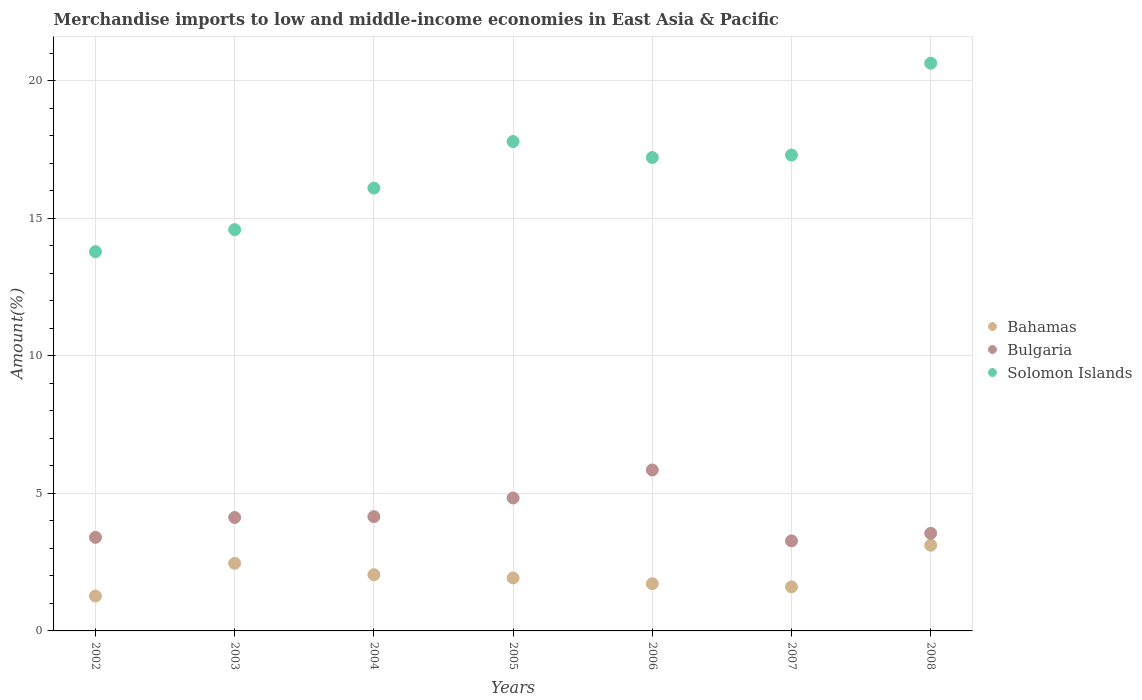How many different coloured dotlines are there?
Keep it short and to the point. 3. What is the percentage of amount earned from merchandise imports in Bahamas in 2006?
Your answer should be very brief. 1.72. Across all years, what is the maximum percentage of amount earned from merchandise imports in Solomon Islands?
Give a very brief answer. 20.64. Across all years, what is the minimum percentage of amount earned from merchandise imports in Bulgaria?
Offer a terse response. 3.27. What is the total percentage of amount earned from merchandise imports in Bahamas in the graph?
Your response must be concise. 14.13. What is the difference between the percentage of amount earned from merchandise imports in Bahamas in 2002 and that in 2008?
Give a very brief answer. -1.85. What is the difference between the percentage of amount earned from merchandise imports in Bulgaria in 2003 and the percentage of amount earned from merchandise imports in Solomon Islands in 2007?
Give a very brief answer. -13.18. What is the average percentage of amount earned from merchandise imports in Solomon Islands per year?
Your answer should be very brief. 16.78. In the year 2006, what is the difference between the percentage of amount earned from merchandise imports in Solomon Islands and percentage of amount earned from merchandise imports in Bulgaria?
Make the answer very short. 11.36. What is the ratio of the percentage of amount earned from merchandise imports in Solomon Islands in 2003 to that in 2007?
Your response must be concise. 0.84. Is the difference between the percentage of amount earned from merchandise imports in Solomon Islands in 2004 and 2007 greater than the difference between the percentage of amount earned from merchandise imports in Bulgaria in 2004 and 2007?
Ensure brevity in your answer.  No. What is the difference between the highest and the second highest percentage of amount earned from merchandise imports in Bulgaria?
Your answer should be compact. 1.02. What is the difference between the highest and the lowest percentage of amount earned from merchandise imports in Bulgaria?
Provide a short and direct response. 2.58. In how many years, is the percentage of amount earned from merchandise imports in Bahamas greater than the average percentage of amount earned from merchandise imports in Bahamas taken over all years?
Offer a very short reply. 3. Is the sum of the percentage of amount earned from merchandise imports in Solomon Islands in 2003 and 2007 greater than the maximum percentage of amount earned from merchandise imports in Bahamas across all years?
Offer a very short reply. Yes. Is it the case that in every year, the sum of the percentage of amount earned from merchandise imports in Bahamas and percentage of amount earned from merchandise imports in Bulgaria  is greater than the percentage of amount earned from merchandise imports in Solomon Islands?
Ensure brevity in your answer.  No. How many years are there in the graph?
Your response must be concise. 7. What is the difference between two consecutive major ticks on the Y-axis?
Provide a short and direct response. 5. Does the graph contain grids?
Provide a short and direct response. Yes. How are the legend labels stacked?
Offer a very short reply. Vertical. What is the title of the graph?
Your answer should be very brief. Merchandise imports to low and middle-income economies in East Asia & Pacific. What is the label or title of the X-axis?
Your answer should be very brief. Years. What is the label or title of the Y-axis?
Your answer should be compact. Amount(%). What is the Amount(%) of Bahamas in 2002?
Ensure brevity in your answer.  1.27. What is the Amount(%) of Bulgaria in 2002?
Ensure brevity in your answer.  3.4. What is the Amount(%) of Solomon Islands in 2002?
Keep it short and to the point. 13.79. What is the Amount(%) in Bahamas in 2003?
Give a very brief answer. 2.46. What is the Amount(%) of Bulgaria in 2003?
Keep it short and to the point. 4.12. What is the Amount(%) of Solomon Islands in 2003?
Ensure brevity in your answer.  14.59. What is the Amount(%) in Bahamas in 2004?
Offer a terse response. 2.04. What is the Amount(%) in Bulgaria in 2004?
Offer a very short reply. 4.15. What is the Amount(%) of Solomon Islands in 2004?
Provide a short and direct response. 16.1. What is the Amount(%) of Bahamas in 2005?
Give a very brief answer. 1.93. What is the Amount(%) of Bulgaria in 2005?
Keep it short and to the point. 4.83. What is the Amount(%) of Solomon Islands in 2005?
Give a very brief answer. 17.79. What is the Amount(%) of Bahamas in 2006?
Your response must be concise. 1.72. What is the Amount(%) in Bulgaria in 2006?
Ensure brevity in your answer.  5.85. What is the Amount(%) of Solomon Islands in 2006?
Offer a terse response. 17.21. What is the Amount(%) of Bahamas in 2007?
Offer a very short reply. 1.6. What is the Amount(%) in Bulgaria in 2007?
Your answer should be very brief. 3.27. What is the Amount(%) of Solomon Islands in 2007?
Ensure brevity in your answer.  17.3. What is the Amount(%) in Bahamas in 2008?
Give a very brief answer. 3.12. What is the Amount(%) of Bulgaria in 2008?
Ensure brevity in your answer.  3.55. What is the Amount(%) in Solomon Islands in 2008?
Provide a succinct answer. 20.64. Across all years, what is the maximum Amount(%) in Bahamas?
Offer a very short reply. 3.12. Across all years, what is the maximum Amount(%) in Bulgaria?
Your answer should be compact. 5.85. Across all years, what is the maximum Amount(%) of Solomon Islands?
Provide a succinct answer. 20.64. Across all years, what is the minimum Amount(%) of Bahamas?
Offer a very short reply. 1.27. Across all years, what is the minimum Amount(%) in Bulgaria?
Provide a succinct answer. 3.27. Across all years, what is the minimum Amount(%) in Solomon Islands?
Make the answer very short. 13.79. What is the total Amount(%) in Bahamas in the graph?
Your response must be concise. 14.13. What is the total Amount(%) of Bulgaria in the graph?
Your response must be concise. 29.19. What is the total Amount(%) in Solomon Islands in the graph?
Your response must be concise. 117.44. What is the difference between the Amount(%) of Bahamas in 2002 and that in 2003?
Your answer should be very brief. -1.19. What is the difference between the Amount(%) of Bulgaria in 2002 and that in 2003?
Keep it short and to the point. -0.72. What is the difference between the Amount(%) of Solomon Islands in 2002 and that in 2003?
Your answer should be very brief. -0.8. What is the difference between the Amount(%) in Bahamas in 2002 and that in 2004?
Make the answer very short. -0.78. What is the difference between the Amount(%) of Bulgaria in 2002 and that in 2004?
Ensure brevity in your answer.  -0.75. What is the difference between the Amount(%) of Solomon Islands in 2002 and that in 2004?
Provide a short and direct response. -2.31. What is the difference between the Amount(%) in Bahamas in 2002 and that in 2005?
Offer a terse response. -0.66. What is the difference between the Amount(%) of Bulgaria in 2002 and that in 2005?
Offer a very short reply. -1.43. What is the difference between the Amount(%) of Solomon Islands in 2002 and that in 2005?
Offer a very short reply. -4. What is the difference between the Amount(%) in Bahamas in 2002 and that in 2006?
Keep it short and to the point. -0.45. What is the difference between the Amount(%) of Bulgaria in 2002 and that in 2006?
Offer a very short reply. -2.45. What is the difference between the Amount(%) of Solomon Islands in 2002 and that in 2006?
Your answer should be compact. -3.42. What is the difference between the Amount(%) in Bahamas in 2002 and that in 2007?
Give a very brief answer. -0.33. What is the difference between the Amount(%) in Bulgaria in 2002 and that in 2007?
Your answer should be compact. 0.13. What is the difference between the Amount(%) of Solomon Islands in 2002 and that in 2007?
Your answer should be compact. -3.51. What is the difference between the Amount(%) in Bahamas in 2002 and that in 2008?
Your answer should be very brief. -1.85. What is the difference between the Amount(%) in Bulgaria in 2002 and that in 2008?
Your response must be concise. -0.15. What is the difference between the Amount(%) of Solomon Islands in 2002 and that in 2008?
Offer a very short reply. -6.85. What is the difference between the Amount(%) of Bahamas in 2003 and that in 2004?
Your answer should be very brief. 0.41. What is the difference between the Amount(%) in Bulgaria in 2003 and that in 2004?
Make the answer very short. -0.03. What is the difference between the Amount(%) of Solomon Islands in 2003 and that in 2004?
Your response must be concise. -1.51. What is the difference between the Amount(%) in Bahamas in 2003 and that in 2005?
Your answer should be compact. 0.53. What is the difference between the Amount(%) of Bulgaria in 2003 and that in 2005?
Your answer should be compact. -0.71. What is the difference between the Amount(%) in Solomon Islands in 2003 and that in 2005?
Your answer should be compact. -3.2. What is the difference between the Amount(%) of Bahamas in 2003 and that in 2006?
Your response must be concise. 0.74. What is the difference between the Amount(%) of Bulgaria in 2003 and that in 2006?
Ensure brevity in your answer.  -1.73. What is the difference between the Amount(%) of Solomon Islands in 2003 and that in 2006?
Offer a terse response. -2.62. What is the difference between the Amount(%) of Bahamas in 2003 and that in 2007?
Offer a very short reply. 0.86. What is the difference between the Amount(%) of Bulgaria in 2003 and that in 2007?
Provide a short and direct response. 0.85. What is the difference between the Amount(%) of Solomon Islands in 2003 and that in 2007?
Ensure brevity in your answer.  -2.71. What is the difference between the Amount(%) in Bahamas in 2003 and that in 2008?
Give a very brief answer. -0.66. What is the difference between the Amount(%) in Bulgaria in 2003 and that in 2008?
Offer a very short reply. 0.57. What is the difference between the Amount(%) in Solomon Islands in 2003 and that in 2008?
Your response must be concise. -6.05. What is the difference between the Amount(%) in Bahamas in 2004 and that in 2005?
Your answer should be very brief. 0.12. What is the difference between the Amount(%) in Bulgaria in 2004 and that in 2005?
Give a very brief answer. -0.68. What is the difference between the Amount(%) of Solomon Islands in 2004 and that in 2005?
Provide a short and direct response. -1.69. What is the difference between the Amount(%) of Bahamas in 2004 and that in 2006?
Provide a succinct answer. 0.33. What is the difference between the Amount(%) of Bulgaria in 2004 and that in 2006?
Provide a succinct answer. -1.7. What is the difference between the Amount(%) in Solomon Islands in 2004 and that in 2006?
Your answer should be very brief. -1.11. What is the difference between the Amount(%) of Bahamas in 2004 and that in 2007?
Provide a short and direct response. 0.44. What is the difference between the Amount(%) in Bulgaria in 2004 and that in 2007?
Ensure brevity in your answer.  0.88. What is the difference between the Amount(%) in Solomon Islands in 2004 and that in 2007?
Ensure brevity in your answer.  -1.2. What is the difference between the Amount(%) in Bahamas in 2004 and that in 2008?
Give a very brief answer. -1.07. What is the difference between the Amount(%) in Bulgaria in 2004 and that in 2008?
Make the answer very short. 0.61. What is the difference between the Amount(%) in Solomon Islands in 2004 and that in 2008?
Provide a short and direct response. -4.54. What is the difference between the Amount(%) in Bahamas in 2005 and that in 2006?
Make the answer very short. 0.21. What is the difference between the Amount(%) of Bulgaria in 2005 and that in 2006?
Your answer should be compact. -1.02. What is the difference between the Amount(%) of Solomon Islands in 2005 and that in 2006?
Your response must be concise. 0.58. What is the difference between the Amount(%) of Bahamas in 2005 and that in 2007?
Give a very brief answer. 0.33. What is the difference between the Amount(%) in Bulgaria in 2005 and that in 2007?
Your answer should be very brief. 1.56. What is the difference between the Amount(%) of Solomon Islands in 2005 and that in 2007?
Your answer should be compact. 0.49. What is the difference between the Amount(%) in Bahamas in 2005 and that in 2008?
Ensure brevity in your answer.  -1.19. What is the difference between the Amount(%) of Bulgaria in 2005 and that in 2008?
Your answer should be compact. 1.29. What is the difference between the Amount(%) of Solomon Islands in 2005 and that in 2008?
Offer a very short reply. -2.85. What is the difference between the Amount(%) in Bahamas in 2006 and that in 2007?
Ensure brevity in your answer.  0.11. What is the difference between the Amount(%) of Bulgaria in 2006 and that in 2007?
Make the answer very short. 2.58. What is the difference between the Amount(%) in Solomon Islands in 2006 and that in 2007?
Offer a terse response. -0.09. What is the difference between the Amount(%) in Bahamas in 2006 and that in 2008?
Offer a terse response. -1.4. What is the difference between the Amount(%) of Bulgaria in 2006 and that in 2008?
Provide a short and direct response. 2.3. What is the difference between the Amount(%) in Solomon Islands in 2006 and that in 2008?
Provide a short and direct response. -3.43. What is the difference between the Amount(%) in Bahamas in 2007 and that in 2008?
Your answer should be compact. -1.51. What is the difference between the Amount(%) in Bulgaria in 2007 and that in 2008?
Ensure brevity in your answer.  -0.28. What is the difference between the Amount(%) in Solomon Islands in 2007 and that in 2008?
Your answer should be very brief. -3.34. What is the difference between the Amount(%) of Bahamas in 2002 and the Amount(%) of Bulgaria in 2003?
Make the answer very short. -2.86. What is the difference between the Amount(%) of Bahamas in 2002 and the Amount(%) of Solomon Islands in 2003?
Offer a terse response. -13.32. What is the difference between the Amount(%) in Bulgaria in 2002 and the Amount(%) in Solomon Islands in 2003?
Keep it short and to the point. -11.19. What is the difference between the Amount(%) of Bahamas in 2002 and the Amount(%) of Bulgaria in 2004?
Offer a very short reply. -2.89. What is the difference between the Amount(%) of Bahamas in 2002 and the Amount(%) of Solomon Islands in 2004?
Make the answer very short. -14.83. What is the difference between the Amount(%) in Bulgaria in 2002 and the Amount(%) in Solomon Islands in 2004?
Give a very brief answer. -12.7. What is the difference between the Amount(%) of Bahamas in 2002 and the Amount(%) of Bulgaria in 2005?
Make the answer very short. -3.57. What is the difference between the Amount(%) of Bahamas in 2002 and the Amount(%) of Solomon Islands in 2005?
Your answer should be very brief. -16.53. What is the difference between the Amount(%) of Bulgaria in 2002 and the Amount(%) of Solomon Islands in 2005?
Keep it short and to the point. -14.39. What is the difference between the Amount(%) in Bahamas in 2002 and the Amount(%) in Bulgaria in 2006?
Provide a short and direct response. -4.58. What is the difference between the Amount(%) in Bahamas in 2002 and the Amount(%) in Solomon Islands in 2006?
Offer a terse response. -15.95. What is the difference between the Amount(%) in Bulgaria in 2002 and the Amount(%) in Solomon Islands in 2006?
Your response must be concise. -13.81. What is the difference between the Amount(%) of Bahamas in 2002 and the Amount(%) of Bulgaria in 2007?
Keep it short and to the point. -2.01. What is the difference between the Amount(%) of Bahamas in 2002 and the Amount(%) of Solomon Islands in 2007?
Your response must be concise. -16.04. What is the difference between the Amount(%) in Bulgaria in 2002 and the Amount(%) in Solomon Islands in 2007?
Your answer should be compact. -13.9. What is the difference between the Amount(%) of Bahamas in 2002 and the Amount(%) of Bulgaria in 2008?
Your answer should be very brief. -2.28. What is the difference between the Amount(%) of Bahamas in 2002 and the Amount(%) of Solomon Islands in 2008?
Your response must be concise. -19.37. What is the difference between the Amount(%) in Bulgaria in 2002 and the Amount(%) in Solomon Islands in 2008?
Your answer should be compact. -17.24. What is the difference between the Amount(%) in Bahamas in 2003 and the Amount(%) in Bulgaria in 2004?
Your answer should be very brief. -1.7. What is the difference between the Amount(%) in Bahamas in 2003 and the Amount(%) in Solomon Islands in 2004?
Keep it short and to the point. -13.64. What is the difference between the Amount(%) in Bulgaria in 2003 and the Amount(%) in Solomon Islands in 2004?
Provide a short and direct response. -11.98. What is the difference between the Amount(%) in Bahamas in 2003 and the Amount(%) in Bulgaria in 2005?
Your answer should be very brief. -2.38. What is the difference between the Amount(%) in Bahamas in 2003 and the Amount(%) in Solomon Islands in 2005?
Give a very brief answer. -15.34. What is the difference between the Amount(%) in Bulgaria in 2003 and the Amount(%) in Solomon Islands in 2005?
Your answer should be compact. -13.67. What is the difference between the Amount(%) of Bahamas in 2003 and the Amount(%) of Bulgaria in 2006?
Give a very brief answer. -3.39. What is the difference between the Amount(%) of Bahamas in 2003 and the Amount(%) of Solomon Islands in 2006?
Ensure brevity in your answer.  -14.76. What is the difference between the Amount(%) in Bulgaria in 2003 and the Amount(%) in Solomon Islands in 2006?
Your answer should be compact. -13.09. What is the difference between the Amount(%) of Bahamas in 2003 and the Amount(%) of Bulgaria in 2007?
Your answer should be very brief. -0.82. What is the difference between the Amount(%) in Bahamas in 2003 and the Amount(%) in Solomon Islands in 2007?
Your answer should be compact. -14.85. What is the difference between the Amount(%) in Bulgaria in 2003 and the Amount(%) in Solomon Islands in 2007?
Your answer should be very brief. -13.18. What is the difference between the Amount(%) of Bahamas in 2003 and the Amount(%) of Bulgaria in 2008?
Your answer should be compact. -1.09. What is the difference between the Amount(%) of Bahamas in 2003 and the Amount(%) of Solomon Islands in 2008?
Your response must be concise. -18.18. What is the difference between the Amount(%) in Bulgaria in 2003 and the Amount(%) in Solomon Islands in 2008?
Ensure brevity in your answer.  -16.52. What is the difference between the Amount(%) in Bahamas in 2004 and the Amount(%) in Bulgaria in 2005?
Your answer should be compact. -2.79. What is the difference between the Amount(%) in Bahamas in 2004 and the Amount(%) in Solomon Islands in 2005?
Give a very brief answer. -15.75. What is the difference between the Amount(%) in Bulgaria in 2004 and the Amount(%) in Solomon Islands in 2005?
Make the answer very short. -13.64. What is the difference between the Amount(%) of Bahamas in 2004 and the Amount(%) of Bulgaria in 2006?
Your answer should be very brief. -3.81. What is the difference between the Amount(%) of Bahamas in 2004 and the Amount(%) of Solomon Islands in 2006?
Offer a terse response. -15.17. What is the difference between the Amount(%) of Bulgaria in 2004 and the Amount(%) of Solomon Islands in 2006?
Make the answer very short. -13.06. What is the difference between the Amount(%) in Bahamas in 2004 and the Amount(%) in Bulgaria in 2007?
Ensure brevity in your answer.  -1.23. What is the difference between the Amount(%) of Bahamas in 2004 and the Amount(%) of Solomon Islands in 2007?
Provide a short and direct response. -15.26. What is the difference between the Amount(%) in Bulgaria in 2004 and the Amount(%) in Solomon Islands in 2007?
Your answer should be compact. -13.15. What is the difference between the Amount(%) in Bahamas in 2004 and the Amount(%) in Bulgaria in 2008?
Keep it short and to the point. -1.5. What is the difference between the Amount(%) in Bahamas in 2004 and the Amount(%) in Solomon Islands in 2008?
Make the answer very short. -18.6. What is the difference between the Amount(%) of Bulgaria in 2004 and the Amount(%) of Solomon Islands in 2008?
Your response must be concise. -16.49. What is the difference between the Amount(%) in Bahamas in 2005 and the Amount(%) in Bulgaria in 2006?
Provide a succinct answer. -3.92. What is the difference between the Amount(%) in Bahamas in 2005 and the Amount(%) in Solomon Islands in 2006?
Your answer should be very brief. -15.29. What is the difference between the Amount(%) in Bulgaria in 2005 and the Amount(%) in Solomon Islands in 2006?
Make the answer very short. -12.38. What is the difference between the Amount(%) in Bahamas in 2005 and the Amount(%) in Bulgaria in 2007?
Provide a short and direct response. -1.35. What is the difference between the Amount(%) of Bahamas in 2005 and the Amount(%) of Solomon Islands in 2007?
Make the answer very short. -15.38. What is the difference between the Amount(%) in Bulgaria in 2005 and the Amount(%) in Solomon Islands in 2007?
Your response must be concise. -12.47. What is the difference between the Amount(%) of Bahamas in 2005 and the Amount(%) of Bulgaria in 2008?
Ensure brevity in your answer.  -1.62. What is the difference between the Amount(%) in Bahamas in 2005 and the Amount(%) in Solomon Islands in 2008?
Your answer should be very brief. -18.72. What is the difference between the Amount(%) of Bulgaria in 2005 and the Amount(%) of Solomon Islands in 2008?
Offer a terse response. -15.81. What is the difference between the Amount(%) of Bahamas in 2006 and the Amount(%) of Bulgaria in 2007?
Provide a short and direct response. -1.56. What is the difference between the Amount(%) in Bahamas in 2006 and the Amount(%) in Solomon Islands in 2007?
Your answer should be very brief. -15.59. What is the difference between the Amount(%) of Bulgaria in 2006 and the Amount(%) of Solomon Islands in 2007?
Offer a very short reply. -11.45. What is the difference between the Amount(%) in Bahamas in 2006 and the Amount(%) in Bulgaria in 2008?
Ensure brevity in your answer.  -1.83. What is the difference between the Amount(%) of Bahamas in 2006 and the Amount(%) of Solomon Islands in 2008?
Make the answer very short. -18.93. What is the difference between the Amount(%) in Bulgaria in 2006 and the Amount(%) in Solomon Islands in 2008?
Offer a terse response. -14.79. What is the difference between the Amount(%) of Bahamas in 2007 and the Amount(%) of Bulgaria in 2008?
Give a very brief answer. -1.95. What is the difference between the Amount(%) in Bahamas in 2007 and the Amount(%) in Solomon Islands in 2008?
Keep it short and to the point. -19.04. What is the difference between the Amount(%) of Bulgaria in 2007 and the Amount(%) of Solomon Islands in 2008?
Make the answer very short. -17.37. What is the average Amount(%) of Bahamas per year?
Give a very brief answer. 2.02. What is the average Amount(%) in Bulgaria per year?
Provide a short and direct response. 4.17. What is the average Amount(%) in Solomon Islands per year?
Provide a short and direct response. 16.78. In the year 2002, what is the difference between the Amount(%) of Bahamas and Amount(%) of Bulgaria?
Your answer should be compact. -2.13. In the year 2002, what is the difference between the Amount(%) of Bahamas and Amount(%) of Solomon Islands?
Offer a terse response. -12.52. In the year 2002, what is the difference between the Amount(%) in Bulgaria and Amount(%) in Solomon Islands?
Offer a very short reply. -10.39. In the year 2003, what is the difference between the Amount(%) in Bahamas and Amount(%) in Bulgaria?
Your answer should be very brief. -1.67. In the year 2003, what is the difference between the Amount(%) of Bahamas and Amount(%) of Solomon Islands?
Ensure brevity in your answer.  -12.13. In the year 2003, what is the difference between the Amount(%) in Bulgaria and Amount(%) in Solomon Islands?
Ensure brevity in your answer.  -10.47. In the year 2004, what is the difference between the Amount(%) in Bahamas and Amount(%) in Bulgaria?
Offer a terse response. -2.11. In the year 2004, what is the difference between the Amount(%) of Bahamas and Amount(%) of Solomon Islands?
Offer a very short reply. -14.06. In the year 2004, what is the difference between the Amount(%) in Bulgaria and Amount(%) in Solomon Islands?
Offer a very short reply. -11.95. In the year 2005, what is the difference between the Amount(%) in Bahamas and Amount(%) in Bulgaria?
Provide a succinct answer. -2.91. In the year 2005, what is the difference between the Amount(%) in Bahamas and Amount(%) in Solomon Islands?
Offer a terse response. -15.87. In the year 2005, what is the difference between the Amount(%) in Bulgaria and Amount(%) in Solomon Islands?
Offer a terse response. -12.96. In the year 2006, what is the difference between the Amount(%) of Bahamas and Amount(%) of Bulgaria?
Keep it short and to the point. -4.13. In the year 2006, what is the difference between the Amount(%) in Bahamas and Amount(%) in Solomon Islands?
Keep it short and to the point. -15.5. In the year 2006, what is the difference between the Amount(%) of Bulgaria and Amount(%) of Solomon Islands?
Ensure brevity in your answer.  -11.36. In the year 2007, what is the difference between the Amount(%) in Bahamas and Amount(%) in Bulgaria?
Your answer should be very brief. -1.67. In the year 2007, what is the difference between the Amount(%) in Bahamas and Amount(%) in Solomon Islands?
Ensure brevity in your answer.  -15.7. In the year 2007, what is the difference between the Amount(%) of Bulgaria and Amount(%) of Solomon Islands?
Provide a succinct answer. -14.03. In the year 2008, what is the difference between the Amount(%) in Bahamas and Amount(%) in Bulgaria?
Provide a succinct answer. -0.43. In the year 2008, what is the difference between the Amount(%) of Bahamas and Amount(%) of Solomon Islands?
Give a very brief answer. -17.53. In the year 2008, what is the difference between the Amount(%) in Bulgaria and Amount(%) in Solomon Islands?
Make the answer very short. -17.09. What is the ratio of the Amount(%) in Bahamas in 2002 to that in 2003?
Offer a very short reply. 0.52. What is the ratio of the Amount(%) of Bulgaria in 2002 to that in 2003?
Your answer should be compact. 0.82. What is the ratio of the Amount(%) in Solomon Islands in 2002 to that in 2003?
Offer a very short reply. 0.95. What is the ratio of the Amount(%) of Bahamas in 2002 to that in 2004?
Your answer should be very brief. 0.62. What is the ratio of the Amount(%) in Bulgaria in 2002 to that in 2004?
Offer a very short reply. 0.82. What is the ratio of the Amount(%) in Solomon Islands in 2002 to that in 2004?
Offer a very short reply. 0.86. What is the ratio of the Amount(%) of Bahamas in 2002 to that in 2005?
Provide a succinct answer. 0.66. What is the ratio of the Amount(%) in Bulgaria in 2002 to that in 2005?
Offer a terse response. 0.7. What is the ratio of the Amount(%) in Solomon Islands in 2002 to that in 2005?
Ensure brevity in your answer.  0.78. What is the ratio of the Amount(%) of Bahamas in 2002 to that in 2006?
Make the answer very short. 0.74. What is the ratio of the Amount(%) of Bulgaria in 2002 to that in 2006?
Your answer should be compact. 0.58. What is the ratio of the Amount(%) in Solomon Islands in 2002 to that in 2006?
Your answer should be compact. 0.8. What is the ratio of the Amount(%) of Bahamas in 2002 to that in 2007?
Keep it short and to the point. 0.79. What is the ratio of the Amount(%) in Bulgaria in 2002 to that in 2007?
Keep it short and to the point. 1.04. What is the ratio of the Amount(%) in Solomon Islands in 2002 to that in 2007?
Offer a terse response. 0.8. What is the ratio of the Amount(%) in Bahamas in 2002 to that in 2008?
Your answer should be very brief. 0.41. What is the ratio of the Amount(%) of Bulgaria in 2002 to that in 2008?
Provide a short and direct response. 0.96. What is the ratio of the Amount(%) in Solomon Islands in 2002 to that in 2008?
Provide a short and direct response. 0.67. What is the ratio of the Amount(%) of Bahamas in 2003 to that in 2004?
Give a very brief answer. 1.2. What is the ratio of the Amount(%) in Solomon Islands in 2003 to that in 2004?
Make the answer very short. 0.91. What is the ratio of the Amount(%) of Bahamas in 2003 to that in 2005?
Offer a very short reply. 1.28. What is the ratio of the Amount(%) of Bulgaria in 2003 to that in 2005?
Provide a short and direct response. 0.85. What is the ratio of the Amount(%) in Solomon Islands in 2003 to that in 2005?
Provide a succinct answer. 0.82. What is the ratio of the Amount(%) of Bahamas in 2003 to that in 2006?
Provide a succinct answer. 1.43. What is the ratio of the Amount(%) in Bulgaria in 2003 to that in 2006?
Give a very brief answer. 0.7. What is the ratio of the Amount(%) in Solomon Islands in 2003 to that in 2006?
Your response must be concise. 0.85. What is the ratio of the Amount(%) of Bahamas in 2003 to that in 2007?
Provide a succinct answer. 1.54. What is the ratio of the Amount(%) of Bulgaria in 2003 to that in 2007?
Your response must be concise. 1.26. What is the ratio of the Amount(%) of Solomon Islands in 2003 to that in 2007?
Make the answer very short. 0.84. What is the ratio of the Amount(%) of Bahamas in 2003 to that in 2008?
Make the answer very short. 0.79. What is the ratio of the Amount(%) in Bulgaria in 2003 to that in 2008?
Give a very brief answer. 1.16. What is the ratio of the Amount(%) in Solomon Islands in 2003 to that in 2008?
Your response must be concise. 0.71. What is the ratio of the Amount(%) of Bahamas in 2004 to that in 2005?
Ensure brevity in your answer.  1.06. What is the ratio of the Amount(%) in Bulgaria in 2004 to that in 2005?
Your answer should be compact. 0.86. What is the ratio of the Amount(%) in Solomon Islands in 2004 to that in 2005?
Ensure brevity in your answer.  0.9. What is the ratio of the Amount(%) of Bahamas in 2004 to that in 2006?
Keep it short and to the point. 1.19. What is the ratio of the Amount(%) in Bulgaria in 2004 to that in 2006?
Ensure brevity in your answer.  0.71. What is the ratio of the Amount(%) of Solomon Islands in 2004 to that in 2006?
Offer a very short reply. 0.94. What is the ratio of the Amount(%) in Bahamas in 2004 to that in 2007?
Provide a succinct answer. 1.28. What is the ratio of the Amount(%) of Bulgaria in 2004 to that in 2007?
Provide a succinct answer. 1.27. What is the ratio of the Amount(%) of Solomon Islands in 2004 to that in 2007?
Your answer should be very brief. 0.93. What is the ratio of the Amount(%) of Bahamas in 2004 to that in 2008?
Give a very brief answer. 0.66. What is the ratio of the Amount(%) in Bulgaria in 2004 to that in 2008?
Your response must be concise. 1.17. What is the ratio of the Amount(%) of Solomon Islands in 2004 to that in 2008?
Give a very brief answer. 0.78. What is the ratio of the Amount(%) of Bahamas in 2005 to that in 2006?
Provide a short and direct response. 1.12. What is the ratio of the Amount(%) of Bulgaria in 2005 to that in 2006?
Your answer should be very brief. 0.83. What is the ratio of the Amount(%) of Solomon Islands in 2005 to that in 2006?
Your answer should be very brief. 1.03. What is the ratio of the Amount(%) in Bahamas in 2005 to that in 2007?
Make the answer very short. 1.2. What is the ratio of the Amount(%) in Bulgaria in 2005 to that in 2007?
Offer a very short reply. 1.48. What is the ratio of the Amount(%) of Solomon Islands in 2005 to that in 2007?
Make the answer very short. 1.03. What is the ratio of the Amount(%) in Bahamas in 2005 to that in 2008?
Your answer should be very brief. 0.62. What is the ratio of the Amount(%) of Bulgaria in 2005 to that in 2008?
Provide a succinct answer. 1.36. What is the ratio of the Amount(%) in Solomon Islands in 2005 to that in 2008?
Ensure brevity in your answer.  0.86. What is the ratio of the Amount(%) in Bahamas in 2006 to that in 2007?
Your answer should be compact. 1.07. What is the ratio of the Amount(%) of Bulgaria in 2006 to that in 2007?
Your response must be concise. 1.79. What is the ratio of the Amount(%) in Bahamas in 2006 to that in 2008?
Give a very brief answer. 0.55. What is the ratio of the Amount(%) of Bulgaria in 2006 to that in 2008?
Your response must be concise. 1.65. What is the ratio of the Amount(%) in Solomon Islands in 2006 to that in 2008?
Keep it short and to the point. 0.83. What is the ratio of the Amount(%) of Bahamas in 2007 to that in 2008?
Your answer should be very brief. 0.51. What is the ratio of the Amount(%) of Bulgaria in 2007 to that in 2008?
Offer a terse response. 0.92. What is the ratio of the Amount(%) of Solomon Islands in 2007 to that in 2008?
Offer a terse response. 0.84. What is the difference between the highest and the second highest Amount(%) in Bahamas?
Your response must be concise. 0.66. What is the difference between the highest and the second highest Amount(%) in Bulgaria?
Your answer should be very brief. 1.02. What is the difference between the highest and the second highest Amount(%) in Solomon Islands?
Ensure brevity in your answer.  2.85. What is the difference between the highest and the lowest Amount(%) in Bahamas?
Give a very brief answer. 1.85. What is the difference between the highest and the lowest Amount(%) of Bulgaria?
Your answer should be compact. 2.58. What is the difference between the highest and the lowest Amount(%) of Solomon Islands?
Provide a short and direct response. 6.85. 